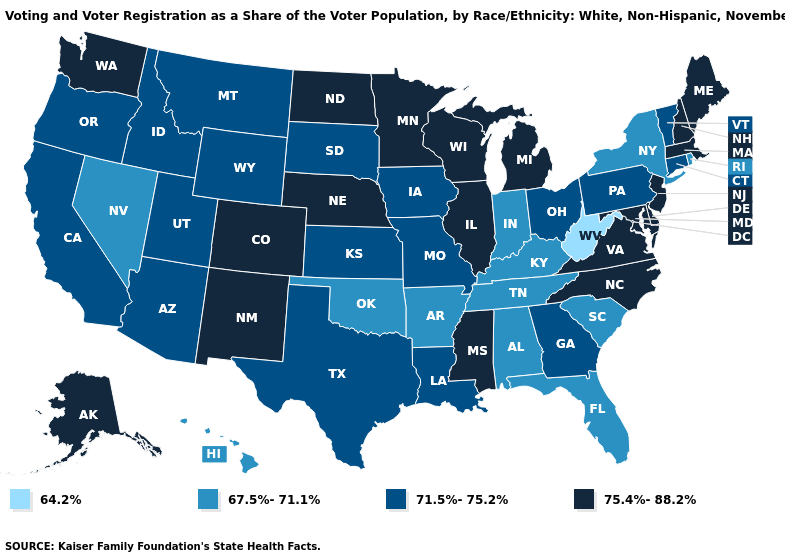Among the states that border Utah , does Nevada have the lowest value?
Concise answer only. Yes. Which states have the lowest value in the USA?
Keep it brief. West Virginia. What is the value of Nebraska?
Concise answer only. 75.4%-88.2%. Does Illinois have a higher value than Hawaii?
Be succinct. Yes. Does North Dakota have the lowest value in the USA?
Answer briefly. No. What is the lowest value in the USA?
Keep it brief. 64.2%. Does Oregon have the lowest value in the West?
Short answer required. No. Name the states that have a value in the range 67.5%-71.1%?
Answer briefly. Alabama, Arkansas, Florida, Hawaii, Indiana, Kentucky, Nevada, New York, Oklahoma, Rhode Island, South Carolina, Tennessee. What is the value of Virginia?
Concise answer only. 75.4%-88.2%. Among the states that border California , does Nevada have the highest value?
Write a very short answer. No. How many symbols are there in the legend?
Quick response, please. 4. What is the highest value in states that border North Dakota?
Be succinct. 75.4%-88.2%. What is the value of Washington?
Give a very brief answer. 75.4%-88.2%. Does Alaska have the lowest value in the USA?
Quick response, please. No. Name the states that have a value in the range 64.2%?
Write a very short answer. West Virginia. 